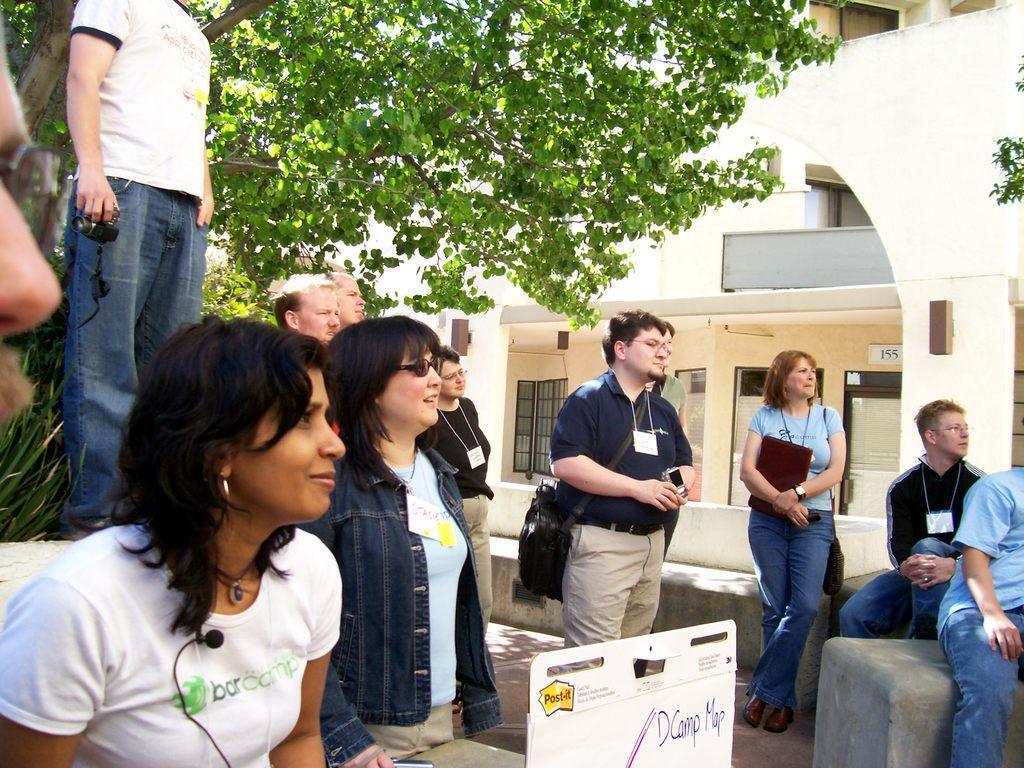In one or two sentences, can you explain what this image depicts? In this picture I can see few people are standing and few are seated and few of them were bags and I can see a man standing and holding a camera in his hand and It looks like a board with some text and I can see trees and a building in the back. 